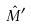Convert formula to latex. <formula><loc_0><loc_0><loc_500><loc_500>\hat { M } ^ { \prime }</formula> 